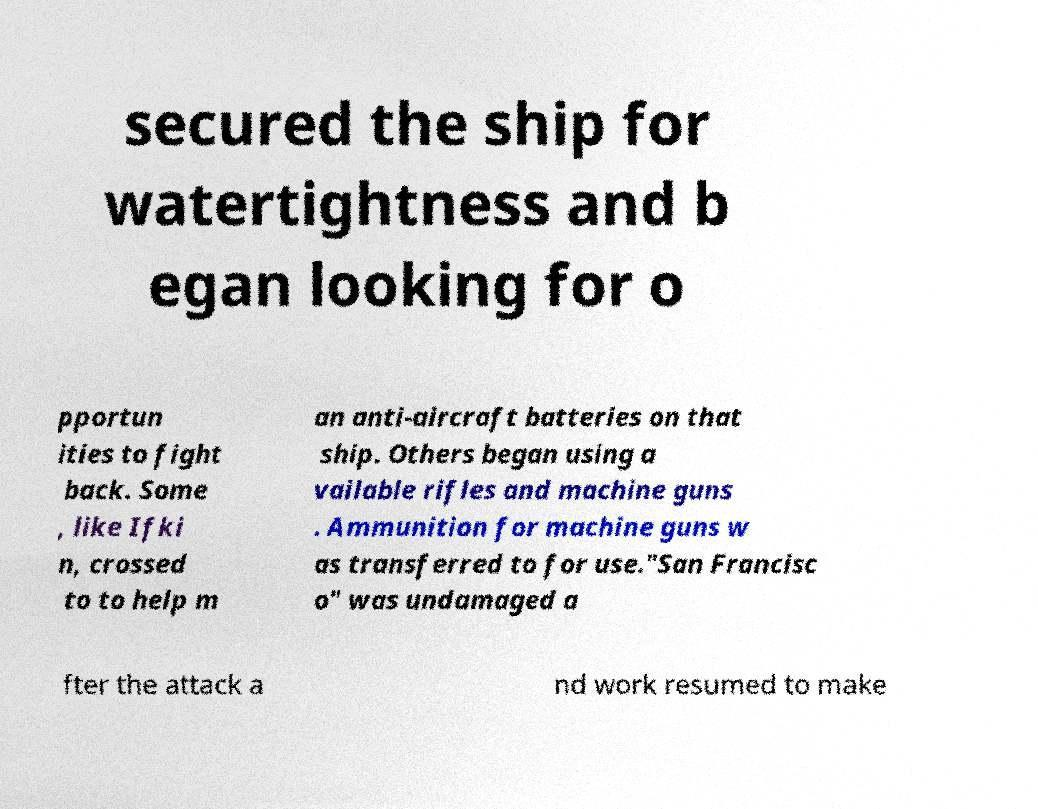What messages or text are displayed in this image? I need them in a readable, typed format. secured the ship for watertightness and b egan looking for o pportun ities to fight back. Some , like Ifki n, crossed to to help m an anti-aircraft batteries on that ship. Others began using a vailable rifles and machine guns . Ammunition for machine guns w as transferred to for use."San Francisc o" was undamaged a fter the attack a nd work resumed to make 